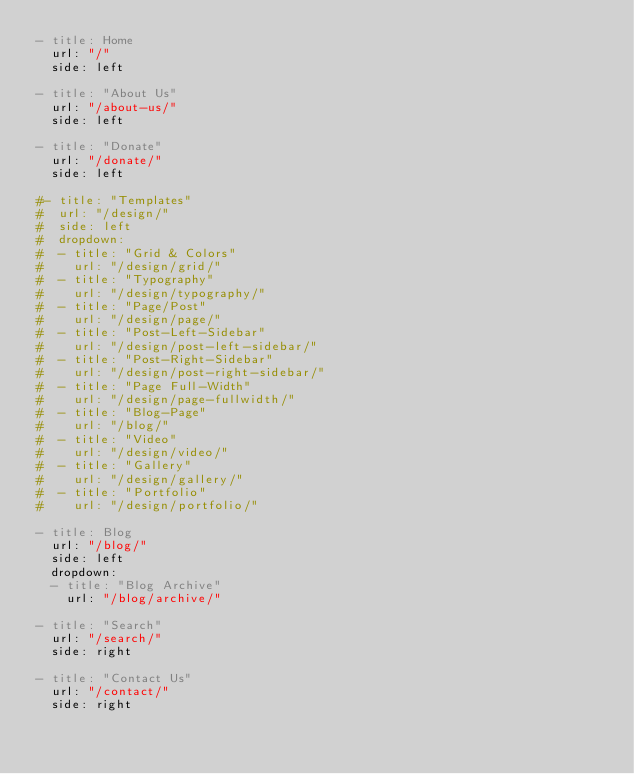Convert code to text. <code><loc_0><loc_0><loc_500><loc_500><_YAML_>- title: Home
  url: "/"
  side: left

- title: "About Us"
  url: "/about-us/"
  side: left
  
- title: "Donate"
  url: "/donate/"
  side: left

#- title: "Templates"
#  url: "/design/"
#  side: left
#  dropdown:
#  - title: "Grid & Colors"
#    url: "/design/grid/"
#  - title: "Typography"
#    url: "/design/typography/"
#  - title: "Page/Post"
#    url: "/design/page/"
#  - title: "Post-Left-Sidebar"
#    url: "/design/post-left-sidebar/"
#  - title: "Post-Right-Sidebar"
#    url: "/design/post-right-sidebar/"
#  - title: "Page Full-Width"
#    url: "/design/page-fullwidth/"
#  - title: "Blog-Page"
#    url: "/blog/"
#  - title: "Video"
#    url: "/design/video/"
#  - title: "Gallery"
#    url: "/design/gallery/"
#  - title: "Portfolio"
#    url: "/design/portfolio/"

- title: Blog
  url: "/blog/"
  side: left
  dropdown:
  - title: "Blog Archive"
    url: "/blog/archive/"

- title: "Search"
  url: "/search/"
  side: right

- title: "Contact Us"
  url: "/contact/"
  side: right
</code> 